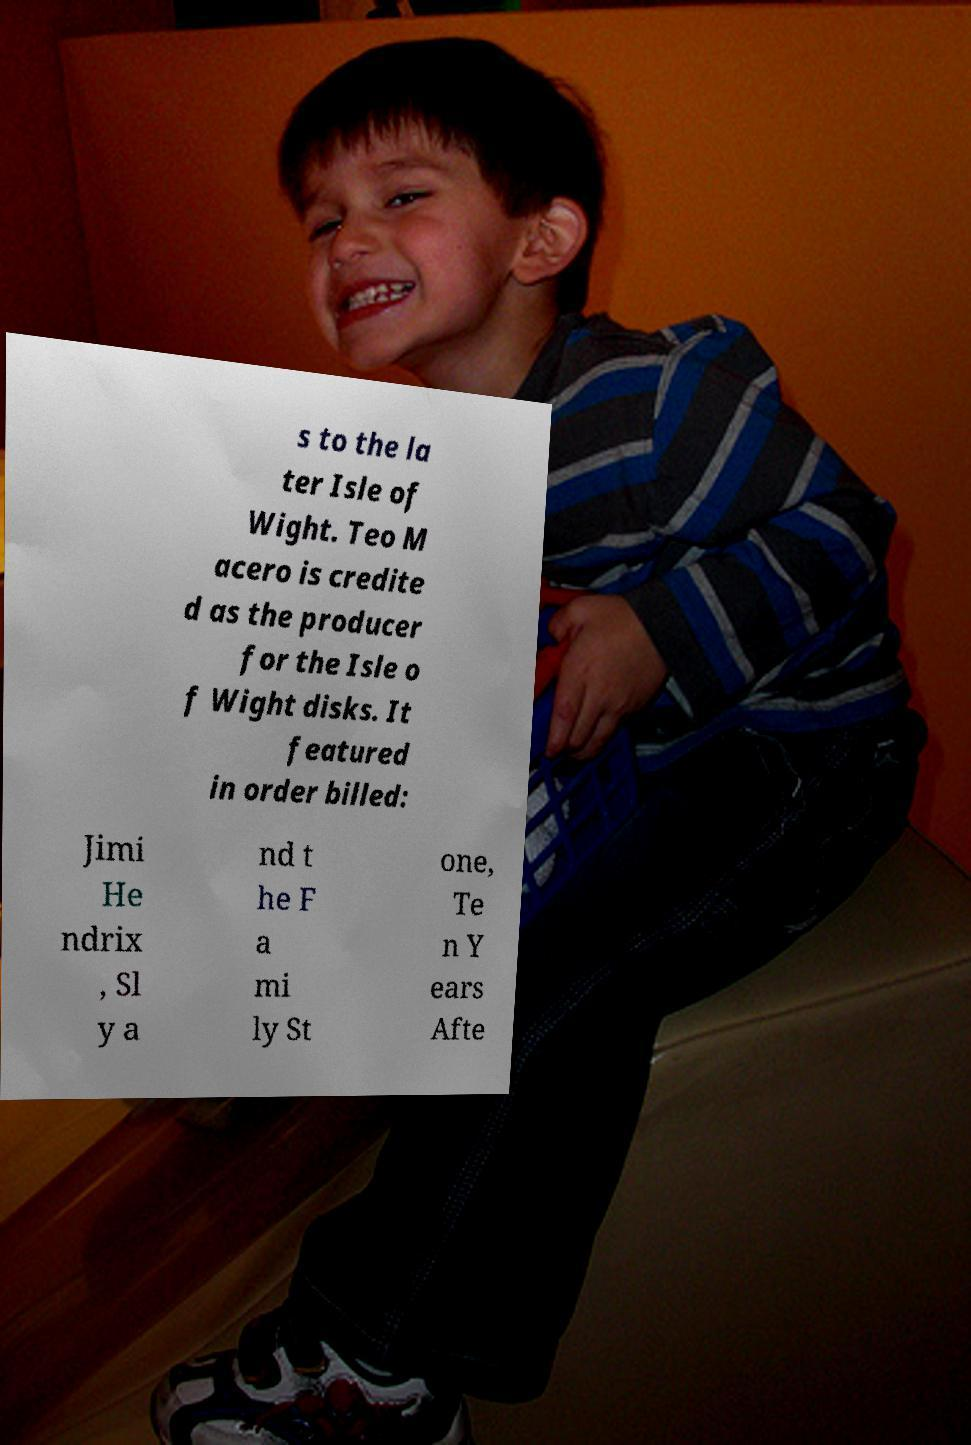For documentation purposes, I need the text within this image transcribed. Could you provide that? s to the la ter Isle of Wight. Teo M acero is credite d as the producer for the Isle o f Wight disks. It featured in order billed: Jimi He ndrix , Sl y a nd t he F a mi ly St one, Te n Y ears Afte 